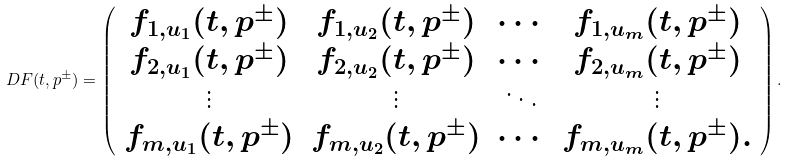Convert formula to latex. <formula><loc_0><loc_0><loc_500><loc_500>D F ( t , p ^ { \pm } ) = \left ( \begin{array} { c c c c } f _ { 1 , u _ { 1 } } ( t , p ^ { \pm } ) & f _ { 1 , u _ { 2 } } ( t , p ^ { \pm } ) & \cdots & f _ { 1 , u _ { m } } ( t , p ^ { \pm } ) \\ f _ { 2 , u _ { 1 } } ( t , p ^ { \pm } ) & f _ { 2 , u _ { 2 } } ( t , p ^ { \pm } ) & \cdots & f _ { 2 , u _ { m } } ( t , p ^ { \pm } ) \\ \vdots & \vdots & \ddots & \vdots \\ f _ { m , u _ { 1 } } ( t , p ^ { \pm } ) & f _ { m , u _ { 2 } } ( t , p ^ { \pm } ) & \cdots & f _ { m , u _ { m } } ( t , p ^ { \pm } ) . \end{array} \right ) .</formula> 